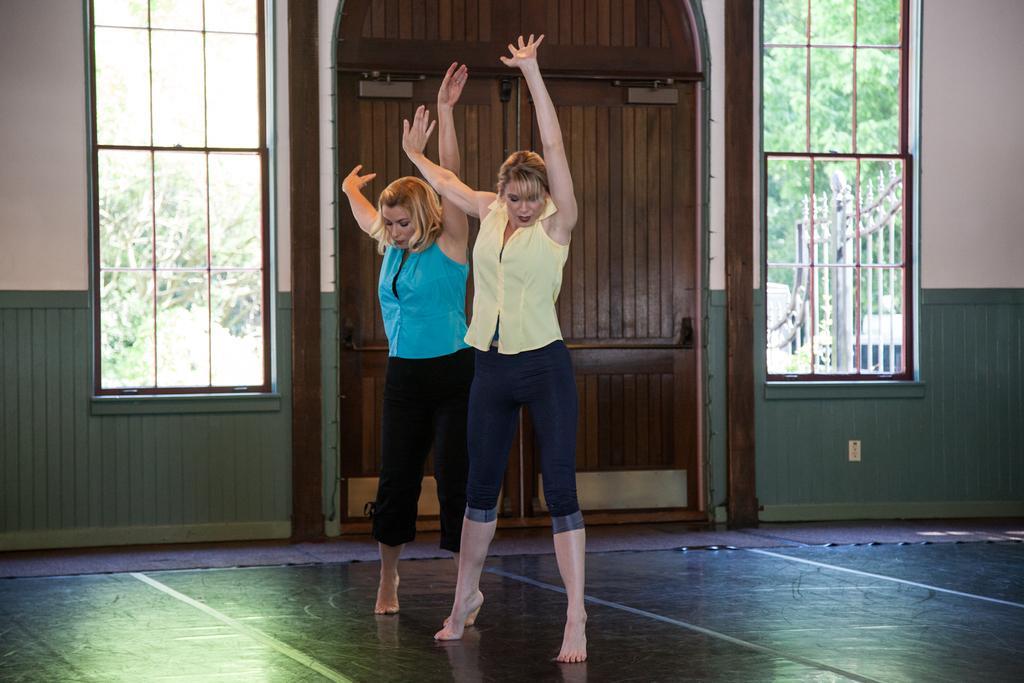Describe this image in one or two sentences. In this picture we can see two women, they are standing, behind them we can see few metal rods, in the background we can find few trees. 